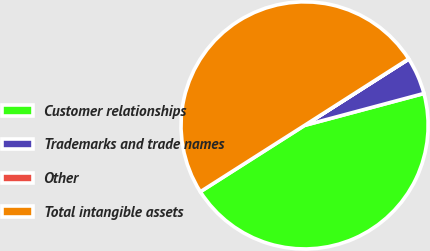Convert chart to OTSL. <chart><loc_0><loc_0><loc_500><loc_500><pie_chart><fcel>Customer relationships<fcel>Trademarks and trade names<fcel>Other<fcel>Total intangible assets<nl><fcel>45.14%<fcel>4.86%<fcel>0.03%<fcel>49.97%<nl></chart> 